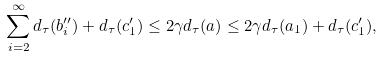<formula> <loc_0><loc_0><loc_500><loc_500>\sum _ { i = 2 } ^ { \infty } d _ { \tau } ( b _ { i } ^ { \prime \prime } ) + d _ { \tau } ( c _ { 1 } ^ { \prime } ) \leq 2 \gamma d _ { \tau } ( a ) \leq 2 \gamma d _ { \tau } ( a _ { 1 } ) + d _ { \tau } ( c _ { 1 } ^ { \prime } ) ,</formula> 